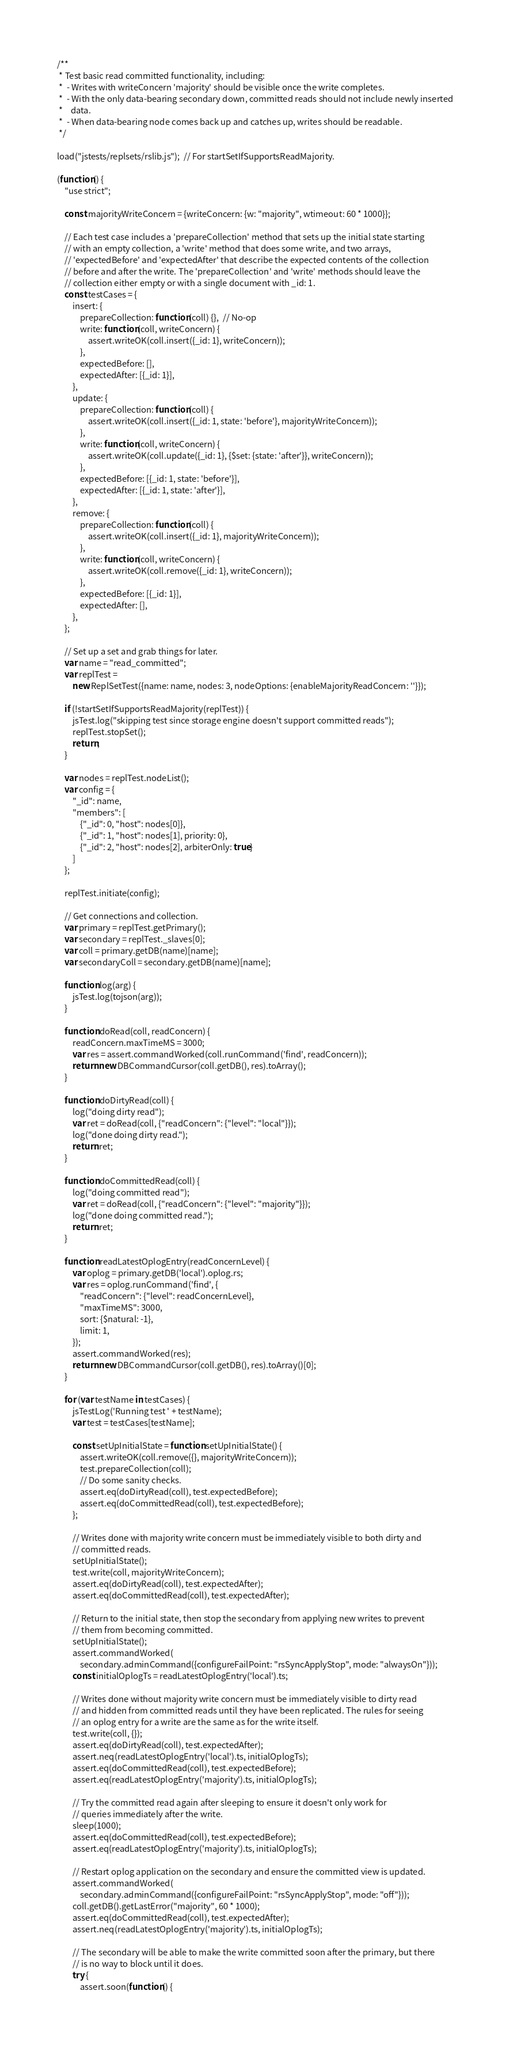Convert code to text. <code><loc_0><loc_0><loc_500><loc_500><_JavaScript_>/**
 * Test basic read committed functionality, including:
 *  - Writes with writeConcern 'majority' should be visible once the write completes.
 *  - With the only data-bearing secondary down, committed reads should not include newly inserted
 *    data.
 *  - When data-bearing node comes back up and catches up, writes should be readable.
 */

load("jstests/replsets/rslib.js");  // For startSetIfSupportsReadMajority.

(function() {
    "use strict";

    const majorityWriteConcern = {writeConcern: {w: "majority", wtimeout: 60 * 1000}};

    // Each test case includes a 'prepareCollection' method that sets up the initial state starting
    // with an empty collection, a 'write' method that does some write, and two arrays,
    // 'expectedBefore' and 'expectedAfter' that describe the expected contents of the collection
    // before and after the write. The 'prepareCollection' and 'write' methods should leave the
    // collection either empty or with a single document with _id: 1.
    const testCases = {
        insert: {
            prepareCollection: function(coll) {},  // No-op
            write: function(coll, writeConcern) {
                assert.writeOK(coll.insert({_id: 1}, writeConcern));
            },
            expectedBefore: [],
            expectedAfter: [{_id: 1}],
        },
        update: {
            prepareCollection: function(coll) {
                assert.writeOK(coll.insert({_id: 1, state: 'before'}, majorityWriteConcern));
            },
            write: function(coll, writeConcern) {
                assert.writeOK(coll.update({_id: 1}, {$set: {state: 'after'}}, writeConcern));
            },
            expectedBefore: [{_id: 1, state: 'before'}],
            expectedAfter: [{_id: 1, state: 'after'}],
        },
        remove: {
            prepareCollection: function(coll) {
                assert.writeOK(coll.insert({_id: 1}, majorityWriteConcern));
            },
            write: function(coll, writeConcern) {
                assert.writeOK(coll.remove({_id: 1}, writeConcern));
            },
            expectedBefore: [{_id: 1}],
            expectedAfter: [],
        },
    };

    // Set up a set and grab things for later.
    var name = "read_committed";
    var replTest =
        new ReplSetTest({name: name, nodes: 3, nodeOptions: {enableMajorityReadConcern: ''}});

    if (!startSetIfSupportsReadMajority(replTest)) {
        jsTest.log("skipping test since storage engine doesn't support committed reads");
        replTest.stopSet();
        return;
    }

    var nodes = replTest.nodeList();
    var config = {
        "_id": name,
        "members": [
            {"_id": 0, "host": nodes[0]},
            {"_id": 1, "host": nodes[1], priority: 0},
            {"_id": 2, "host": nodes[2], arbiterOnly: true}
        ]
    };

    replTest.initiate(config);

    // Get connections and collection.
    var primary = replTest.getPrimary();
    var secondary = replTest._slaves[0];
    var coll = primary.getDB(name)[name];
    var secondaryColl = secondary.getDB(name)[name];

    function log(arg) {
        jsTest.log(tojson(arg));
    }

    function doRead(coll, readConcern) {
        readConcern.maxTimeMS = 3000;
        var res = assert.commandWorked(coll.runCommand('find', readConcern));
        return new DBCommandCursor(coll.getDB(), res).toArray();
    }

    function doDirtyRead(coll) {
        log("doing dirty read");
        var ret = doRead(coll, {"readConcern": {"level": "local"}});
        log("done doing dirty read.");
        return ret;
    }

    function doCommittedRead(coll) {
        log("doing committed read");
        var ret = doRead(coll, {"readConcern": {"level": "majority"}});
        log("done doing committed read.");
        return ret;
    }

    function readLatestOplogEntry(readConcernLevel) {
        var oplog = primary.getDB('local').oplog.rs;
        var res = oplog.runCommand('find', {
            "readConcern": {"level": readConcernLevel},
            "maxTimeMS": 3000,
            sort: {$natural: -1},
            limit: 1,
        });
        assert.commandWorked(res);
        return new DBCommandCursor(coll.getDB(), res).toArray()[0];
    }

    for (var testName in testCases) {
        jsTestLog('Running test ' + testName);
        var test = testCases[testName];

        const setUpInitialState = function setUpInitialState() {
            assert.writeOK(coll.remove({}, majorityWriteConcern));
            test.prepareCollection(coll);
            // Do some sanity checks.
            assert.eq(doDirtyRead(coll), test.expectedBefore);
            assert.eq(doCommittedRead(coll), test.expectedBefore);
        };

        // Writes done with majority write concern must be immediately visible to both dirty and
        // committed reads.
        setUpInitialState();
        test.write(coll, majorityWriteConcern);
        assert.eq(doDirtyRead(coll), test.expectedAfter);
        assert.eq(doCommittedRead(coll), test.expectedAfter);

        // Return to the initial state, then stop the secondary from applying new writes to prevent
        // them from becoming committed.
        setUpInitialState();
        assert.commandWorked(
            secondary.adminCommand({configureFailPoint: "rsSyncApplyStop", mode: "alwaysOn"}));
        const initialOplogTs = readLatestOplogEntry('local').ts;

        // Writes done without majority write concern must be immediately visible to dirty read
        // and hidden from committed reads until they have been replicated. The rules for seeing
        // an oplog entry for a write are the same as for the write itself.
        test.write(coll, {});
        assert.eq(doDirtyRead(coll), test.expectedAfter);
        assert.neq(readLatestOplogEntry('local').ts, initialOplogTs);
        assert.eq(doCommittedRead(coll), test.expectedBefore);
        assert.eq(readLatestOplogEntry('majority').ts, initialOplogTs);

        // Try the committed read again after sleeping to ensure it doesn't only work for
        // queries immediately after the write.
        sleep(1000);
        assert.eq(doCommittedRead(coll), test.expectedBefore);
        assert.eq(readLatestOplogEntry('majority').ts, initialOplogTs);

        // Restart oplog application on the secondary and ensure the committed view is updated.
        assert.commandWorked(
            secondary.adminCommand({configureFailPoint: "rsSyncApplyStop", mode: "off"}));
        coll.getDB().getLastError("majority", 60 * 1000);
        assert.eq(doCommittedRead(coll), test.expectedAfter);
        assert.neq(readLatestOplogEntry('majority').ts, initialOplogTs);

        // The secondary will be able to make the write committed soon after the primary, but there
        // is no way to block until it does.
        try {
            assert.soon(function() {</code> 